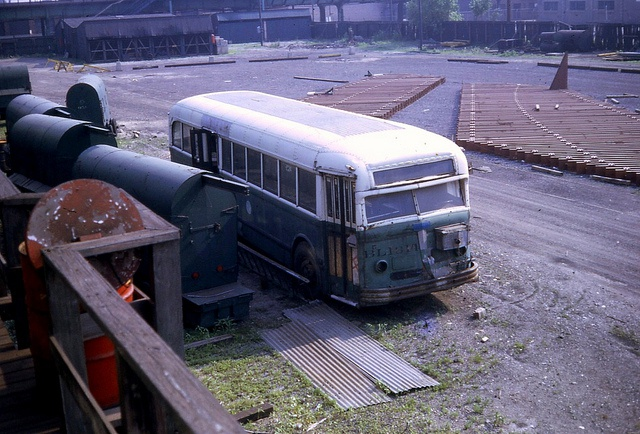Describe the objects in this image and their specific colors. I can see bus in blue, black, lavender, and gray tones in this image. 